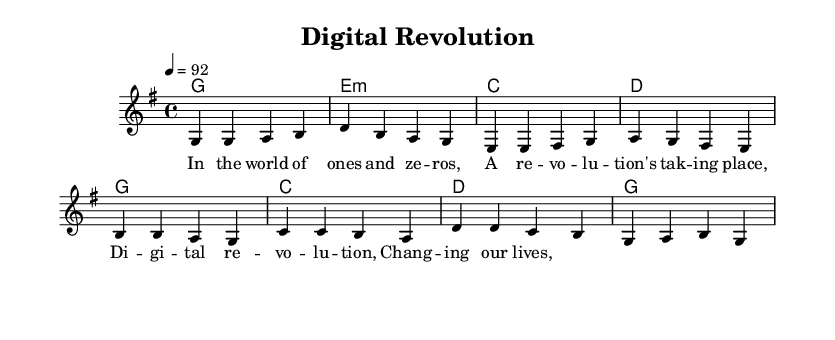what is the key signature of this music? The key signature is indicated right after the clef and shows one sharp (F#), which indicates that it is in G major.
Answer: G major what is the time signature? The time signature is represented by the numbers at the beginning of the staff, showing that there are four beats in each measure, with a quarter note receiving one beat.
Answer: 4/4 what is the tempo marking? The tempo marking is located in the global block, indicating how fast the music should be played; in this case, it states 92 beats per minute.
Answer: 92 how many bars are in the chorus section? To find the number of bars in the chorus, we can count the measures in the chorusChords section, which consists of four measures.
Answer: 4 what chords are used in the verse? By examining the verseChords section, we see the chords represented: G major, E minor, C major, and D major.
Answer: G, E minor, C, D what is the primary theme of the lyrics? Analyzing the lyrics presented, the theme focuses on the digital revolution and its effects, which is suggested in the repeated phrase "Digital revolution, Changing our lives."
Answer: Digital revolution what musical genre does this piece represent? Looking at the rhythmic elements, syncopation, and the overall upbeat feel, the music fits the characteristics of reggae, which often celebrates innovation and positivity.
Answer: Reggae 